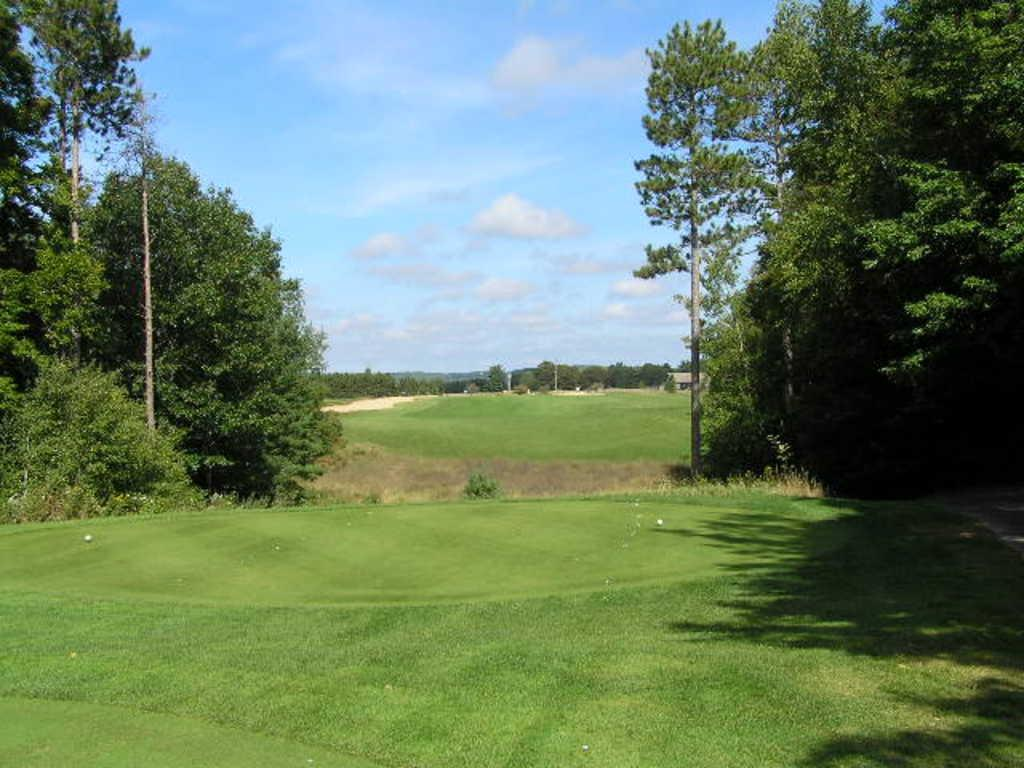What type of vegetation is on the ground in the image? There is grass on the ground in the image. What can be seen on the sides of the image? There are trees on the sides in the image. What is visible in the background of the image? There are trees and the sky visible in the background of the image. What can be seen in the sky? Clouds are present in the sky. Are there any bears visible in the image? No, there are no bears present in the image. What type of straw is used to create the path in the image? There is no path made of straw in the image; it features grass, trees, and a sky with clouds. 